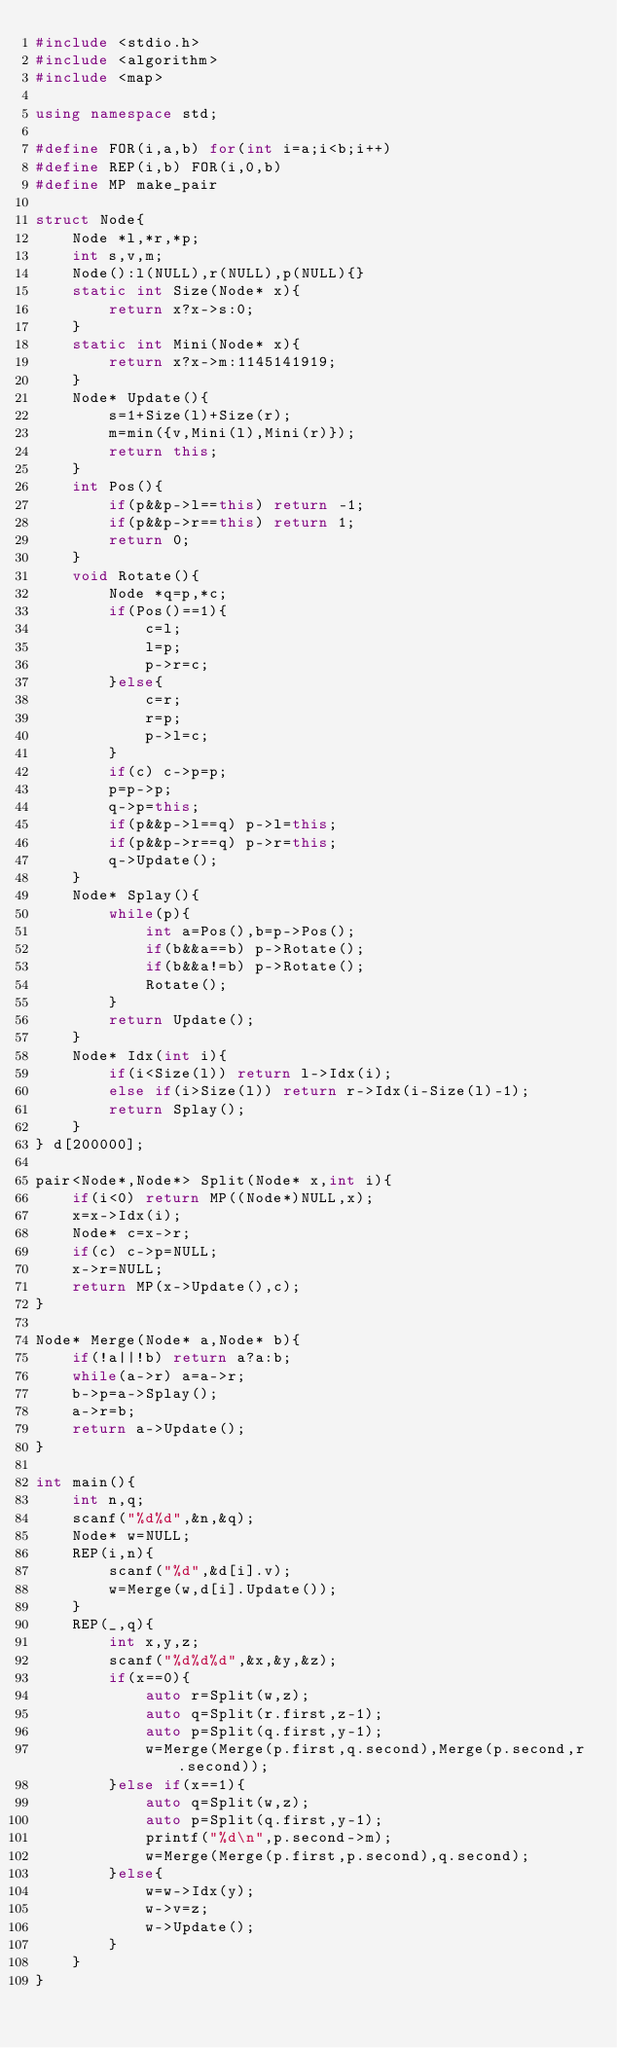<code> <loc_0><loc_0><loc_500><loc_500><_C++_>#include <stdio.h>
#include <algorithm>
#include <map>

using namespace std;

#define FOR(i,a,b) for(int i=a;i<b;i++)
#define REP(i,b) FOR(i,0,b)
#define MP make_pair
	
struct Node{
	Node *l,*r,*p;
	int s,v,m;
	Node():l(NULL),r(NULL),p(NULL){}
	static int Size(Node* x){
		return x?x->s:0;
	}
	static int Mini(Node* x){
		return x?x->m:1145141919;
	}
	Node* Update(){
		s=1+Size(l)+Size(r);
		m=min({v,Mini(l),Mini(r)});
		return this;
	}
	int Pos(){
		if(p&&p->l==this) return -1;
		if(p&&p->r==this) return 1;
		return 0;
	}
	void Rotate(){
		Node *q=p,*c;
		if(Pos()==1){
			c=l;
			l=p;
			p->r=c;
		}else{
			c=r;
			r=p;
			p->l=c;
		}
		if(c) c->p=p;
		p=p->p;
		q->p=this;
		if(p&&p->l==q) p->l=this;
		if(p&&p->r==q) p->r=this;
		q->Update();
	}
	Node* Splay(){
		while(p){
			int a=Pos(),b=p->Pos();
			if(b&&a==b) p->Rotate();
			if(b&&a!=b) p->Rotate();
			Rotate();
		}
		return Update();
	}
	Node* Idx(int i){
		if(i<Size(l)) return l->Idx(i);
		else if(i>Size(l)) return r->Idx(i-Size(l)-1);
		return Splay();
	}
} d[200000];

pair<Node*,Node*> Split(Node* x,int i){
	if(i<0) return MP((Node*)NULL,x);
	x=x->Idx(i);
	Node* c=x->r;
	if(c) c->p=NULL;
	x->r=NULL;
	return MP(x->Update(),c);
}

Node* Merge(Node* a,Node* b){
	if(!a||!b) return a?a:b;
	while(a->r) a=a->r;
	b->p=a->Splay();
	a->r=b;
	return a->Update();
}

int main(){
	int n,q;
	scanf("%d%d",&n,&q);
	Node* w=NULL;
	REP(i,n){
		scanf("%d",&d[i].v);
		w=Merge(w,d[i].Update());
	}
	REP(_,q){
		int x,y,z;
		scanf("%d%d%d",&x,&y,&z);
		if(x==0){
			auto r=Split(w,z);
			auto q=Split(r.first,z-1);
			auto p=Split(q.first,y-1);
			w=Merge(Merge(p.first,q.second),Merge(p.second,r.second));
		}else if(x==1){
			auto q=Split(w,z);
			auto p=Split(q.first,y-1);
			printf("%d\n",p.second->m);
			w=Merge(Merge(p.first,p.second),q.second);
		}else{
			w=w->Idx(y);
			w->v=z;
			w->Update();
		}
	}
}</code> 